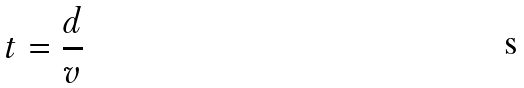Convert formula to latex. <formula><loc_0><loc_0><loc_500><loc_500>t = \frac { d } { v }</formula> 